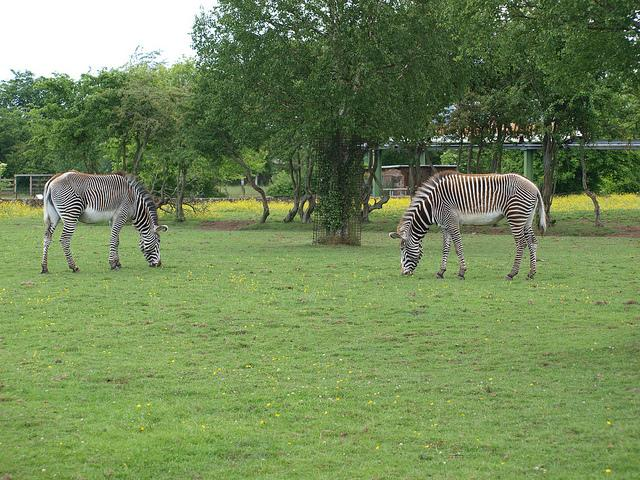The zebras in the middle of the field are busy doing what? Please explain your reasoning. eating grass. The zebras are snacking. 